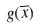<formula> <loc_0><loc_0><loc_500><loc_500>g ( \overline { x } )</formula> 